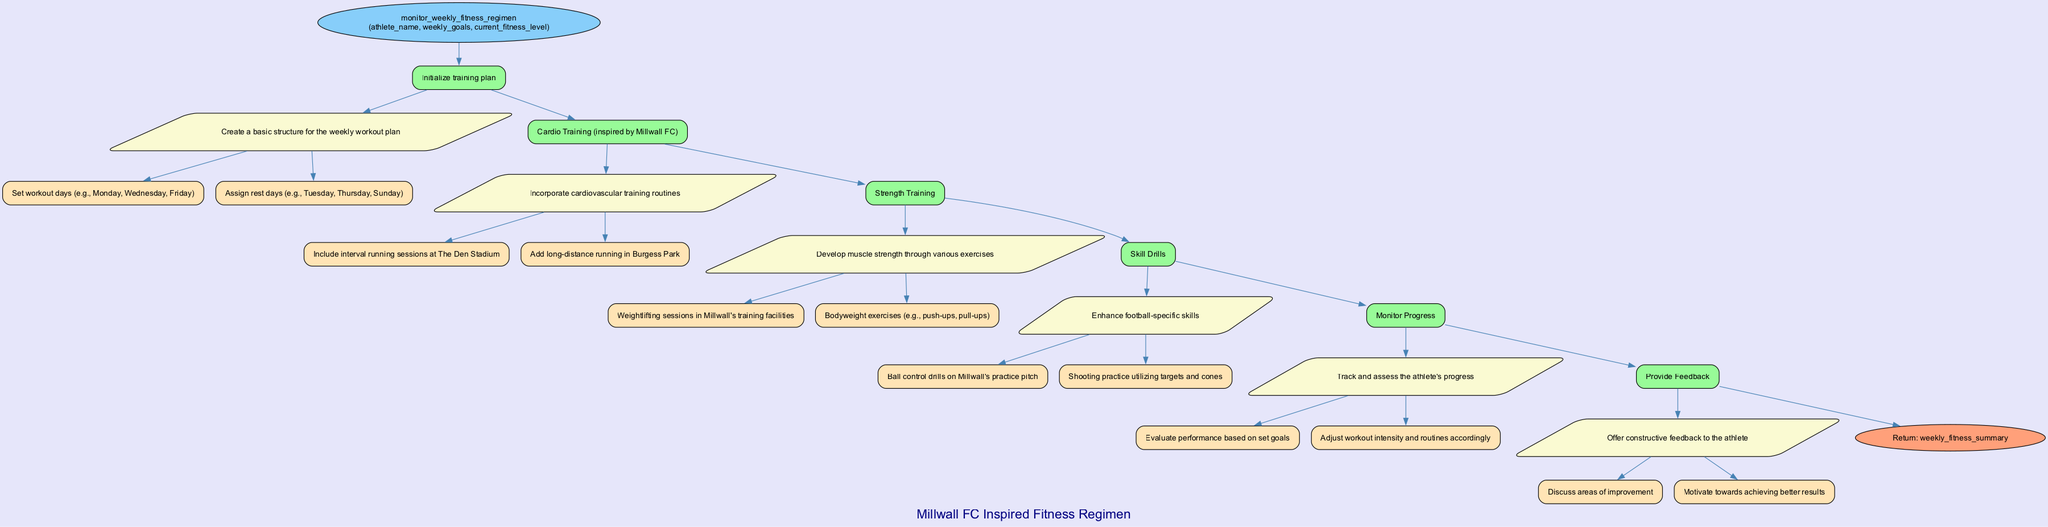What is the name of the function in the diagram? The diagram lists the function name at the start node, which is "monitor_weekly_fitness_regimen."
Answer: monitor_weekly_fitness_regimen How many steps are included in the weekly fitness regimen? By counting the individual steps listed in the diagram, there are a total of 6 steps outlined for the weekly fitness regimen.
Answer: 6 Which step focuses on incorporating cardiovascular training routines? The second step in the flowchart is specifically dedicated to cardio training, as described in its step description as "Cardio Training (inspired by Millwall FC)."
Answer: Cardio Training (inspired by Millwall FC) What is the final action taken in the function before returning a value? The last step before returning a value is the "Provide Feedback" step, which offers constructive feedback to the athlete.
Answer: Provide Feedback What type of training includes weightlifting sessions? The third step, labeled "Strength Training," indicates that weightlifting sessions are a part of this training routine.
Answer: Strength Training Which day is designated as a rest day according to the training plan? The initialization step specifies the rest days, which includes Tuesday as one of the assigned rest days.
Answer: Tuesday How does the diagram indicate the overall inspiration for the training regimen? At the top of the diagram, there is a label stating "Millwall FC Inspired Fitness Regimen," which conveys that the entire training plan is influenced by Millwall FC.
Answer: Millwall FC Inspired Fitness Regimen What is the return value of the function? At the end of the flowchart, the return value is specified as "weekly_fitness_summary," indicating the outcome of the function.
Answer: weekly_fitness_summary Which set of exercises is featured under skill drills? The step describing skill drills includes "Ball control drills on Millwall's practice pitch" and "Shooting practice utilizing targets and cones," indicating football-specific skill development.
Answer: Ball control drills on Millwall's practice pitch and Shooting practice utilizing targets and cones 